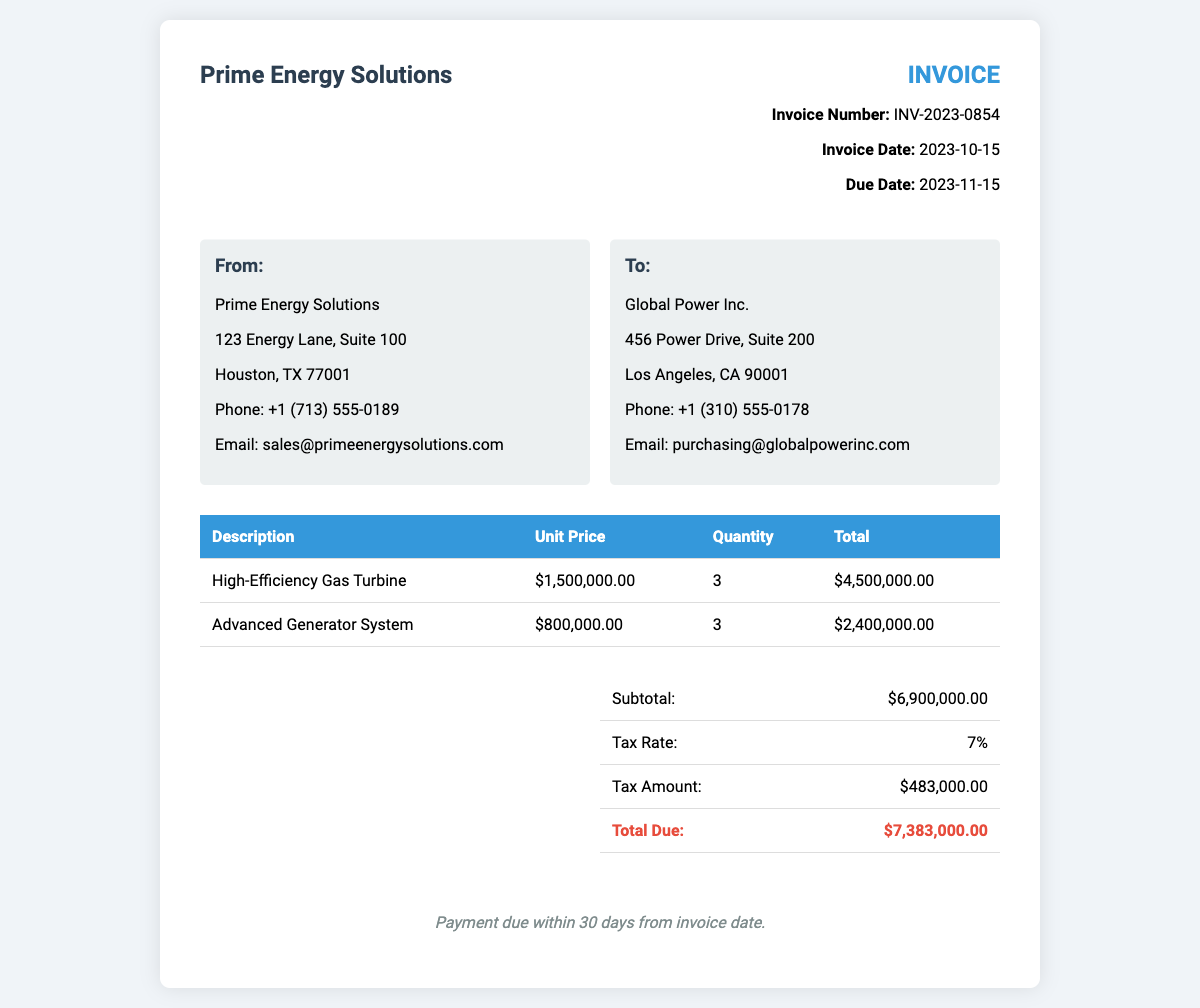What is the invoice number? The invoice number is stated near the top of the document as a unique identifier for the transaction.
Answer: INV-2023-0854 What is the invoice date? The invoice date represents when the invoice was issued, mentioned in the invoice details section.
Answer: 2023-10-15 Who is the sender of the invoice? The sender is presented in the address box labeled "From" at the beginning of the document.
Answer: Prime Energy Solutions What is the total amount due? The total amount due is calculated as the sum of the subtotal and tax, indicated in the total section of the invoice.
Answer: $7,383,000.00 How many high-efficiency gas turbines were purchased? The quantity of turbines purchased is detailed in the table under the "Quantity" column for the respective item.
Answer: 3 What is the tax rate applied to the invoice? The tax rate is specified in the total section of the invoice, providing the percentage applicable to the subtotal.
Answer: 7% What is the subtotal of the invoice? The subtotal is the total before taxes and is shown in the total section of the invoice document.
Answer: $6,900,000.00 What is the payment term for this invoice? The payment term outlines how long the buyer has to remit payment, indicated at the bottom of the document.
Answer: 30 days Who is the recipient of the invoice? The recipient is identified in the address box labeled "To," which contains the company name and address details.
Answer: Global Power Inc 